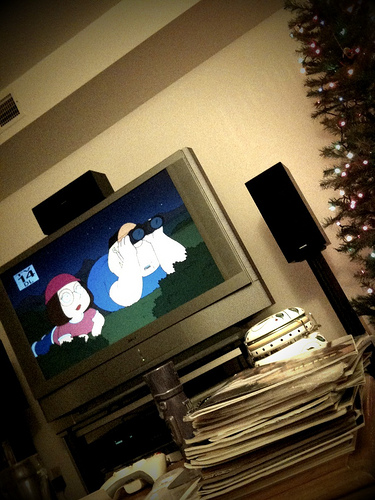<image>
Is the speaker next to the christmas tree? Yes. The speaker is positioned adjacent to the christmas tree, located nearby in the same general area. 